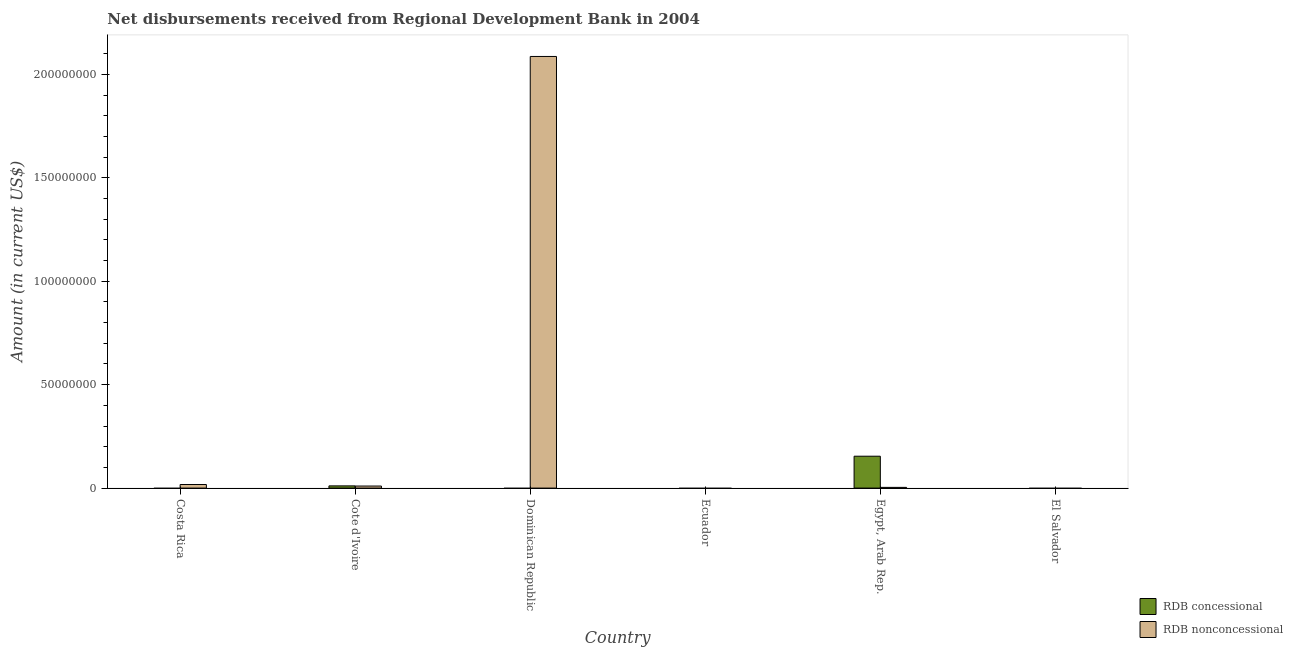Are the number of bars per tick equal to the number of legend labels?
Give a very brief answer. No. How many bars are there on the 2nd tick from the right?
Offer a very short reply. 2. What is the label of the 5th group of bars from the left?
Keep it short and to the point. Egypt, Arab Rep. In how many cases, is the number of bars for a given country not equal to the number of legend labels?
Provide a short and direct response. 4. Across all countries, what is the maximum net concessional disbursements from rdb?
Your answer should be compact. 1.54e+07. Across all countries, what is the minimum net non concessional disbursements from rdb?
Offer a terse response. 0. In which country was the net concessional disbursements from rdb maximum?
Ensure brevity in your answer.  Egypt, Arab Rep. What is the total net non concessional disbursements from rdb in the graph?
Ensure brevity in your answer.  2.12e+08. What is the difference between the net non concessional disbursements from rdb in Costa Rica and that in Dominican Republic?
Give a very brief answer. -2.07e+08. What is the difference between the net concessional disbursements from rdb in Costa Rica and the net non concessional disbursements from rdb in Dominican Republic?
Provide a short and direct response. -2.09e+08. What is the average net non concessional disbursements from rdb per country?
Your answer should be very brief. 3.53e+07. What is the difference between the net non concessional disbursements from rdb and net concessional disbursements from rdb in Egypt, Arab Rep.?
Your answer should be compact. -1.51e+07. In how many countries, is the net concessional disbursements from rdb greater than 110000000 US$?
Provide a short and direct response. 0. What is the ratio of the net non concessional disbursements from rdb in Costa Rica to that in Cote d'Ivoire?
Keep it short and to the point. 1.75. What is the difference between the highest and the second highest net non concessional disbursements from rdb?
Offer a very short reply. 2.07e+08. What is the difference between the highest and the lowest net non concessional disbursements from rdb?
Give a very brief answer. 2.09e+08. In how many countries, is the net non concessional disbursements from rdb greater than the average net non concessional disbursements from rdb taken over all countries?
Your answer should be very brief. 1. How many bars are there?
Ensure brevity in your answer.  6. Are all the bars in the graph horizontal?
Ensure brevity in your answer.  No. Where does the legend appear in the graph?
Provide a succinct answer. Bottom right. How are the legend labels stacked?
Provide a short and direct response. Vertical. What is the title of the graph?
Offer a very short reply. Net disbursements received from Regional Development Bank in 2004. Does "Lower secondary rate" appear as one of the legend labels in the graph?
Your answer should be very brief. No. What is the label or title of the Y-axis?
Keep it short and to the point. Amount (in current US$). What is the Amount (in current US$) in RDB nonconcessional in Costa Rica?
Offer a very short reply. 1.74e+06. What is the Amount (in current US$) in RDB concessional in Cote d'Ivoire?
Your answer should be very brief. 1.07e+06. What is the Amount (in current US$) of RDB nonconcessional in Cote d'Ivoire?
Offer a very short reply. 9.91e+05. What is the Amount (in current US$) in RDB nonconcessional in Dominican Republic?
Provide a succinct answer. 2.09e+08. What is the Amount (in current US$) in RDB concessional in Ecuador?
Your answer should be very brief. 0. What is the Amount (in current US$) of RDB nonconcessional in Ecuador?
Ensure brevity in your answer.  0. What is the Amount (in current US$) in RDB concessional in Egypt, Arab Rep.?
Your answer should be compact. 1.54e+07. What is the Amount (in current US$) of RDB nonconcessional in Egypt, Arab Rep.?
Offer a very short reply. 3.41e+05. Across all countries, what is the maximum Amount (in current US$) in RDB concessional?
Make the answer very short. 1.54e+07. Across all countries, what is the maximum Amount (in current US$) in RDB nonconcessional?
Your answer should be very brief. 2.09e+08. Across all countries, what is the minimum Amount (in current US$) of RDB concessional?
Keep it short and to the point. 0. Across all countries, what is the minimum Amount (in current US$) in RDB nonconcessional?
Make the answer very short. 0. What is the total Amount (in current US$) of RDB concessional in the graph?
Ensure brevity in your answer.  1.65e+07. What is the total Amount (in current US$) of RDB nonconcessional in the graph?
Offer a very short reply. 2.12e+08. What is the difference between the Amount (in current US$) of RDB nonconcessional in Costa Rica and that in Cote d'Ivoire?
Provide a short and direct response. 7.44e+05. What is the difference between the Amount (in current US$) of RDB nonconcessional in Costa Rica and that in Dominican Republic?
Offer a very short reply. -2.07e+08. What is the difference between the Amount (in current US$) of RDB nonconcessional in Costa Rica and that in Egypt, Arab Rep.?
Provide a short and direct response. 1.39e+06. What is the difference between the Amount (in current US$) of RDB nonconcessional in Cote d'Ivoire and that in Dominican Republic?
Ensure brevity in your answer.  -2.08e+08. What is the difference between the Amount (in current US$) of RDB concessional in Cote d'Ivoire and that in Egypt, Arab Rep.?
Keep it short and to the point. -1.43e+07. What is the difference between the Amount (in current US$) of RDB nonconcessional in Cote d'Ivoire and that in Egypt, Arab Rep.?
Your answer should be compact. 6.50e+05. What is the difference between the Amount (in current US$) of RDB nonconcessional in Dominican Republic and that in Egypt, Arab Rep.?
Provide a succinct answer. 2.08e+08. What is the difference between the Amount (in current US$) in RDB concessional in Cote d'Ivoire and the Amount (in current US$) in RDB nonconcessional in Dominican Republic?
Provide a succinct answer. -2.08e+08. What is the difference between the Amount (in current US$) of RDB concessional in Cote d'Ivoire and the Amount (in current US$) of RDB nonconcessional in Egypt, Arab Rep.?
Provide a short and direct response. 7.29e+05. What is the average Amount (in current US$) of RDB concessional per country?
Give a very brief answer. 2.75e+06. What is the average Amount (in current US$) of RDB nonconcessional per country?
Provide a succinct answer. 3.53e+07. What is the difference between the Amount (in current US$) in RDB concessional and Amount (in current US$) in RDB nonconcessional in Cote d'Ivoire?
Offer a terse response. 7.90e+04. What is the difference between the Amount (in current US$) of RDB concessional and Amount (in current US$) of RDB nonconcessional in Egypt, Arab Rep.?
Keep it short and to the point. 1.51e+07. What is the ratio of the Amount (in current US$) of RDB nonconcessional in Costa Rica to that in Cote d'Ivoire?
Keep it short and to the point. 1.75. What is the ratio of the Amount (in current US$) of RDB nonconcessional in Costa Rica to that in Dominican Republic?
Offer a very short reply. 0.01. What is the ratio of the Amount (in current US$) in RDB nonconcessional in Costa Rica to that in Egypt, Arab Rep.?
Offer a terse response. 5.09. What is the ratio of the Amount (in current US$) in RDB nonconcessional in Cote d'Ivoire to that in Dominican Republic?
Offer a terse response. 0. What is the ratio of the Amount (in current US$) of RDB concessional in Cote d'Ivoire to that in Egypt, Arab Rep.?
Offer a terse response. 0.07. What is the ratio of the Amount (in current US$) of RDB nonconcessional in Cote d'Ivoire to that in Egypt, Arab Rep.?
Keep it short and to the point. 2.91. What is the ratio of the Amount (in current US$) in RDB nonconcessional in Dominican Republic to that in Egypt, Arab Rep.?
Your answer should be very brief. 611.93. What is the difference between the highest and the second highest Amount (in current US$) in RDB nonconcessional?
Keep it short and to the point. 2.07e+08. What is the difference between the highest and the lowest Amount (in current US$) of RDB concessional?
Your answer should be compact. 1.54e+07. What is the difference between the highest and the lowest Amount (in current US$) of RDB nonconcessional?
Your answer should be very brief. 2.09e+08. 